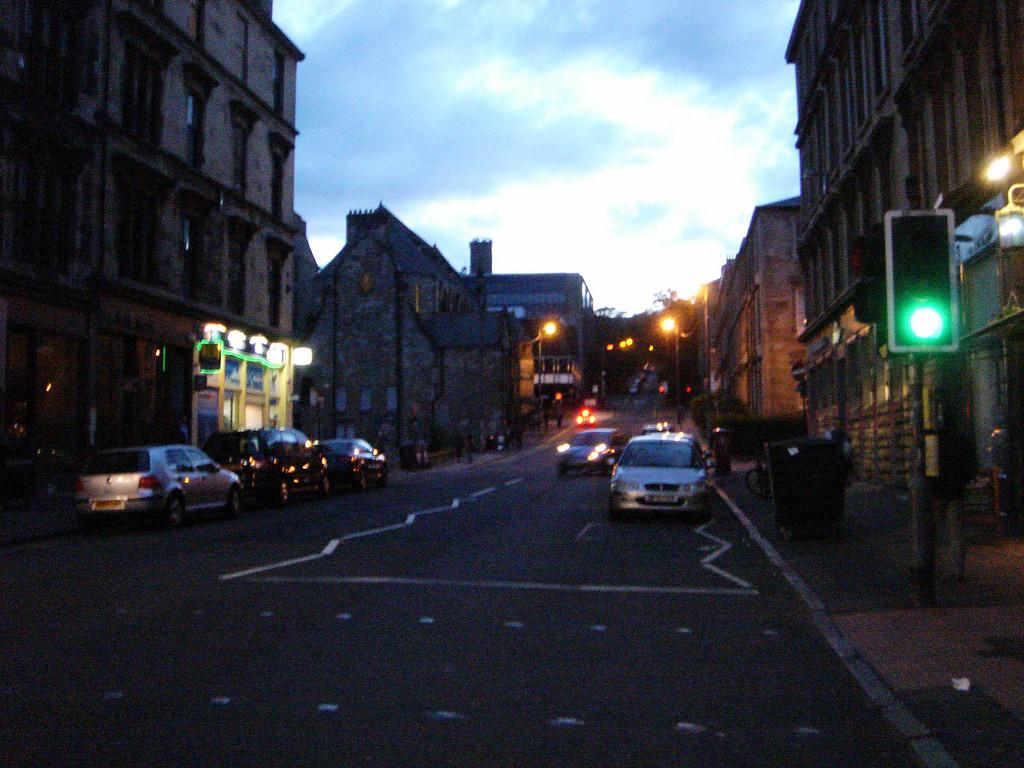What type of structures can be seen in the image? There are buildings in the image. What else can be seen on the ground in the image? There are vehicles on the ground in the image. What type of lighting is present in the image? There are street lights in the image. What objects are present on the ground in the image? There are boxes in the image. What type of signal is present in the image? There is a traffic light in the image. What part of the natural environment is visible in the image? The sky is visible in the image. What scent can be detected in the image? There is no information about scents in the image, as it only provides visual information. 